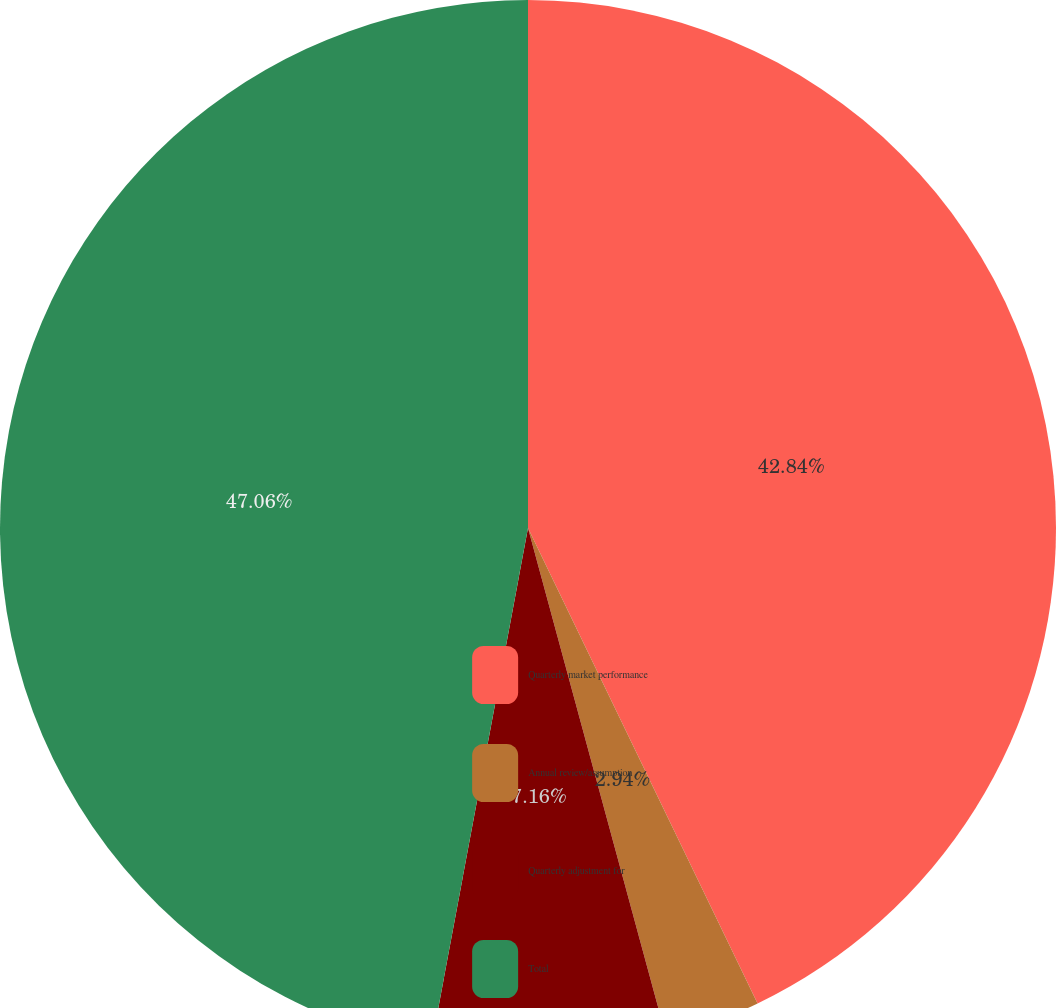Convert chart to OTSL. <chart><loc_0><loc_0><loc_500><loc_500><pie_chart><fcel>Quarterly market performance<fcel>Annual review/assumption<fcel>Quarterly adjustment for<fcel>Total<nl><fcel>42.84%<fcel>2.94%<fcel>7.16%<fcel>47.06%<nl></chart> 